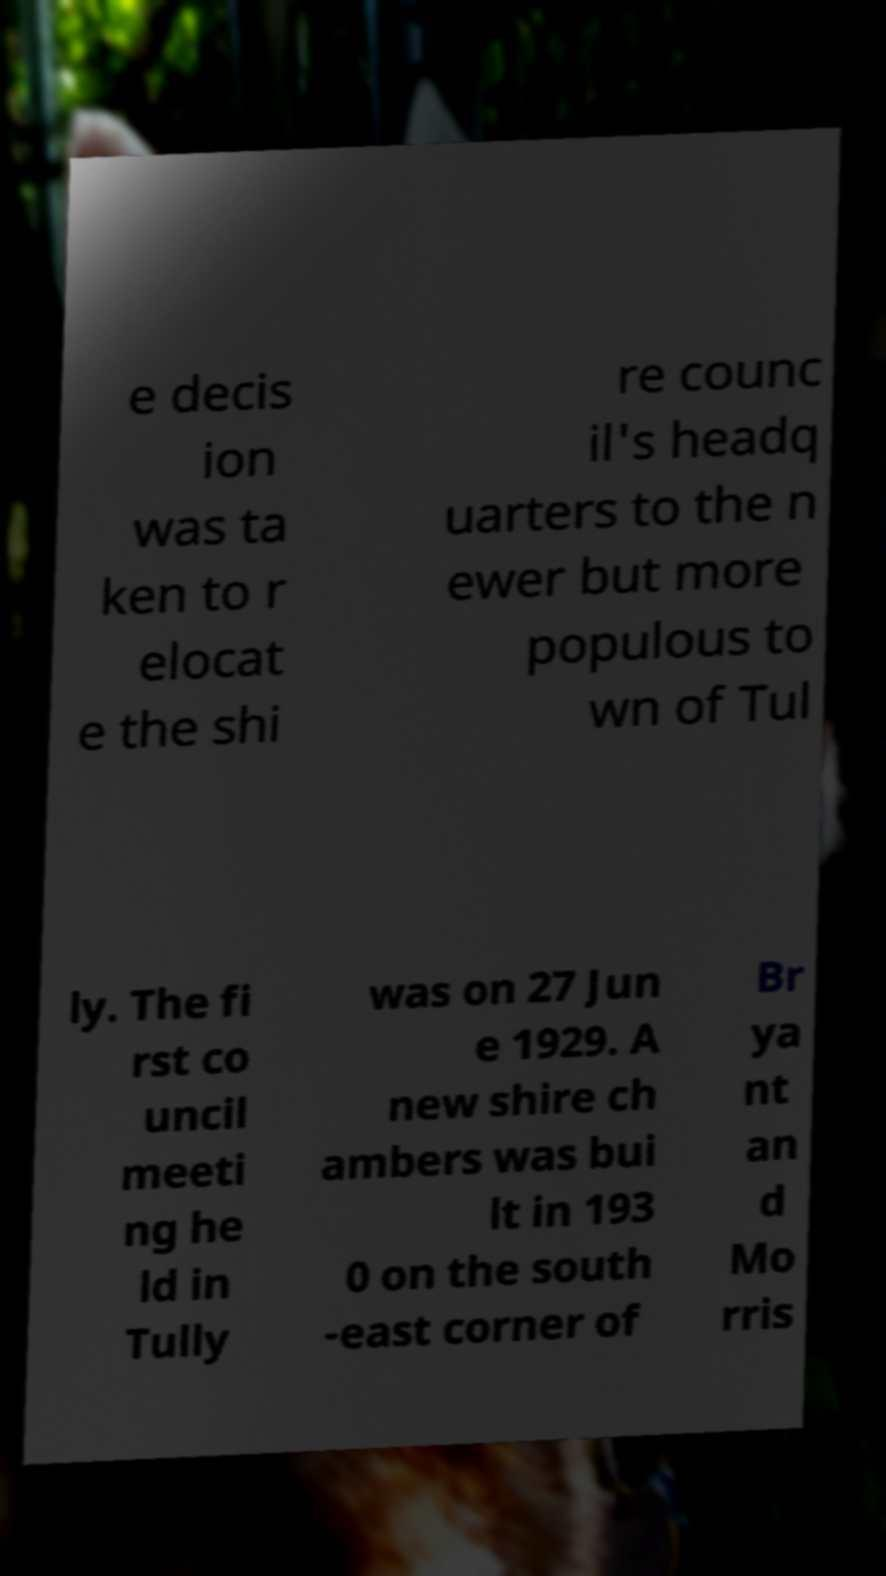Can you read and provide the text displayed in the image?This photo seems to have some interesting text. Can you extract and type it out for me? e decis ion was ta ken to r elocat e the shi re counc il's headq uarters to the n ewer but more populous to wn of Tul ly. The fi rst co uncil meeti ng he ld in Tully was on 27 Jun e 1929. A new shire ch ambers was bui lt in 193 0 on the south -east corner of Br ya nt an d Mo rris 